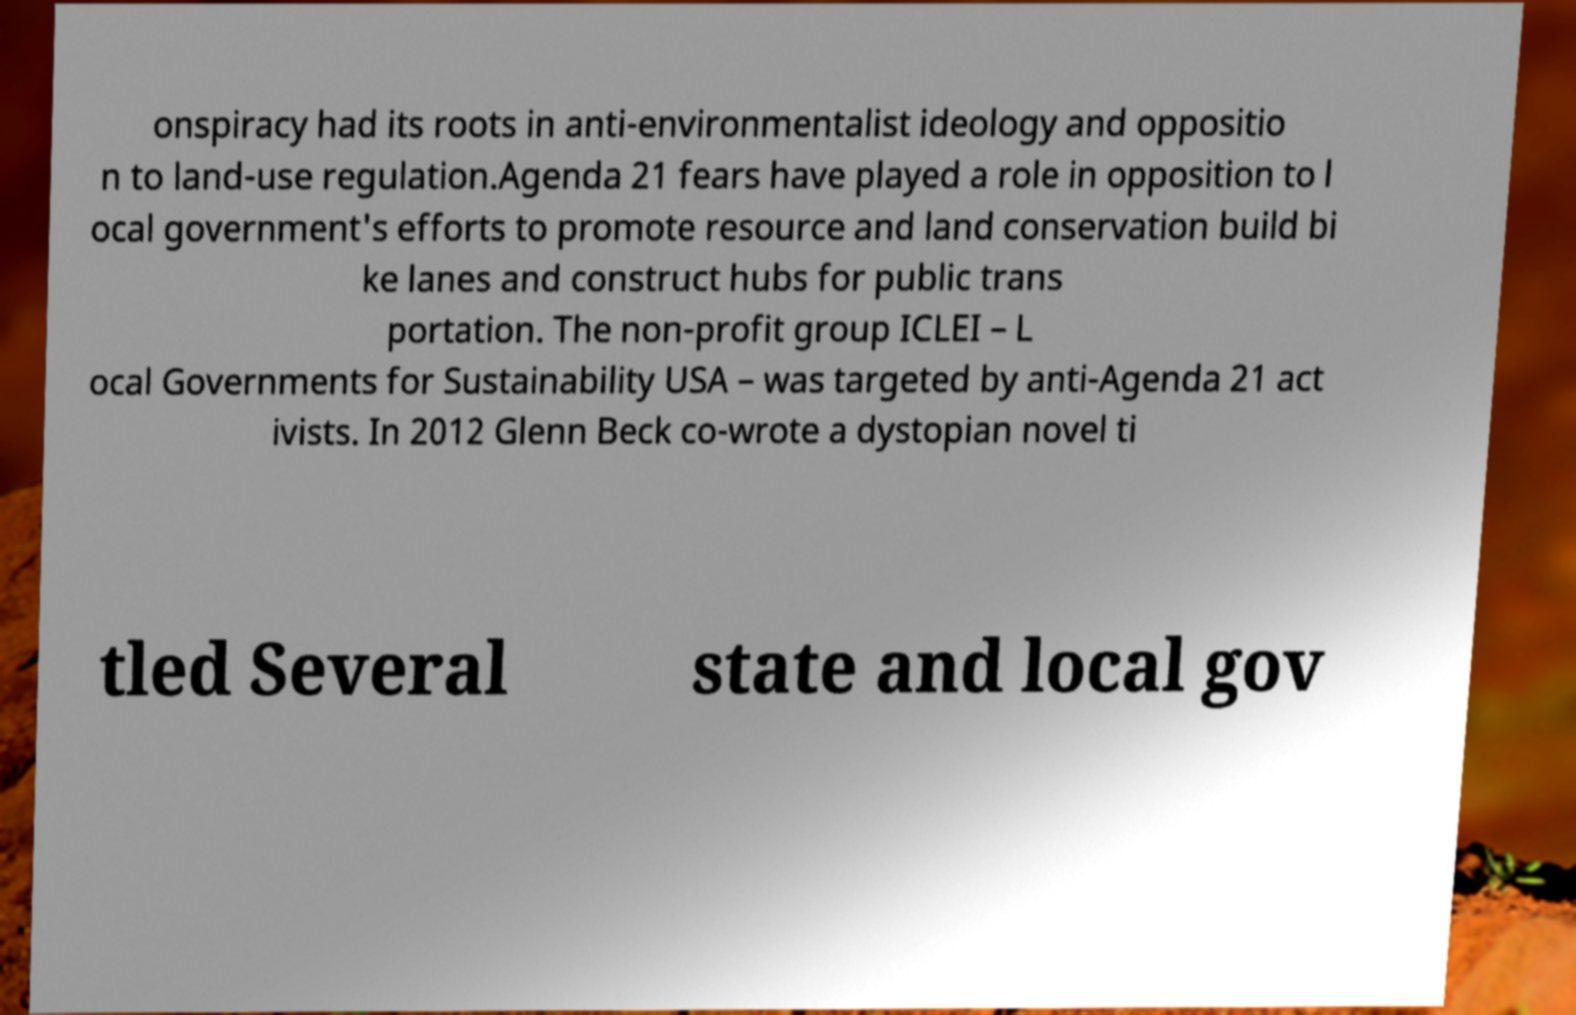Please identify and transcribe the text found in this image. onspiracy had its roots in anti-environmentalist ideology and oppositio n to land-use regulation.Agenda 21 fears have played a role in opposition to l ocal government's efforts to promote resource and land conservation build bi ke lanes and construct hubs for public trans portation. The non-profit group ICLEI – L ocal Governments for Sustainability USA – was targeted by anti-Agenda 21 act ivists. In 2012 Glenn Beck co-wrote a dystopian novel ti tled Several state and local gov 